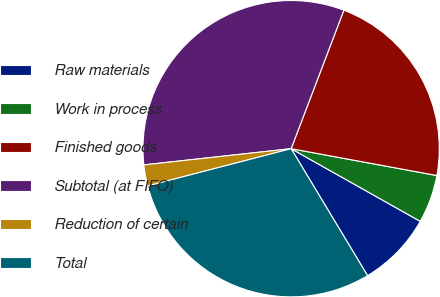<chart> <loc_0><loc_0><loc_500><loc_500><pie_chart><fcel>Raw materials<fcel>Work in process<fcel>Finished goods<fcel>Subtotal (at FIFO)<fcel>Reduction of certain<fcel>Total<nl><fcel>8.22%<fcel>5.26%<fcel>22.11%<fcel>32.54%<fcel>2.3%<fcel>29.58%<nl></chart> 